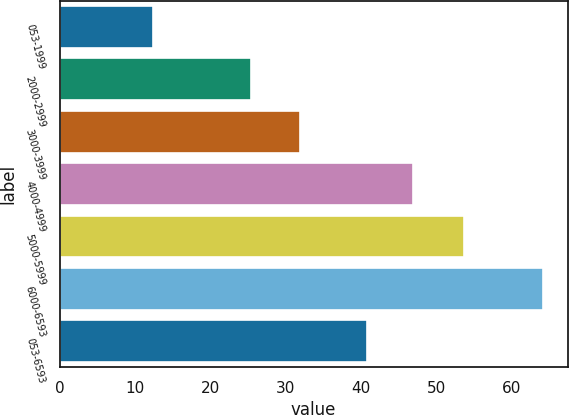<chart> <loc_0><loc_0><loc_500><loc_500><bar_chart><fcel>053-1999<fcel>2000-2999<fcel>3000-3999<fcel>4000-4999<fcel>5000-5999<fcel>6000-6593<fcel>053-6593<nl><fcel>12.42<fcel>25.37<fcel>31.83<fcel>46.88<fcel>53.62<fcel>64.17<fcel>40.75<nl></chart> 